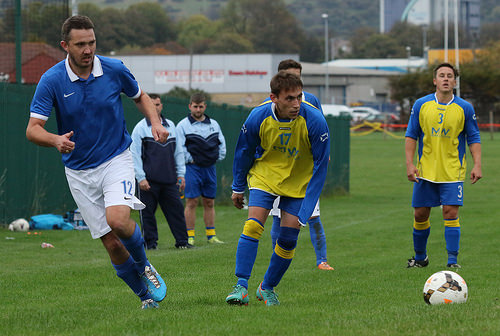<image>
Can you confirm if the football is in front of the player? Yes. The football is positioned in front of the player, appearing closer to the camera viewpoint. 